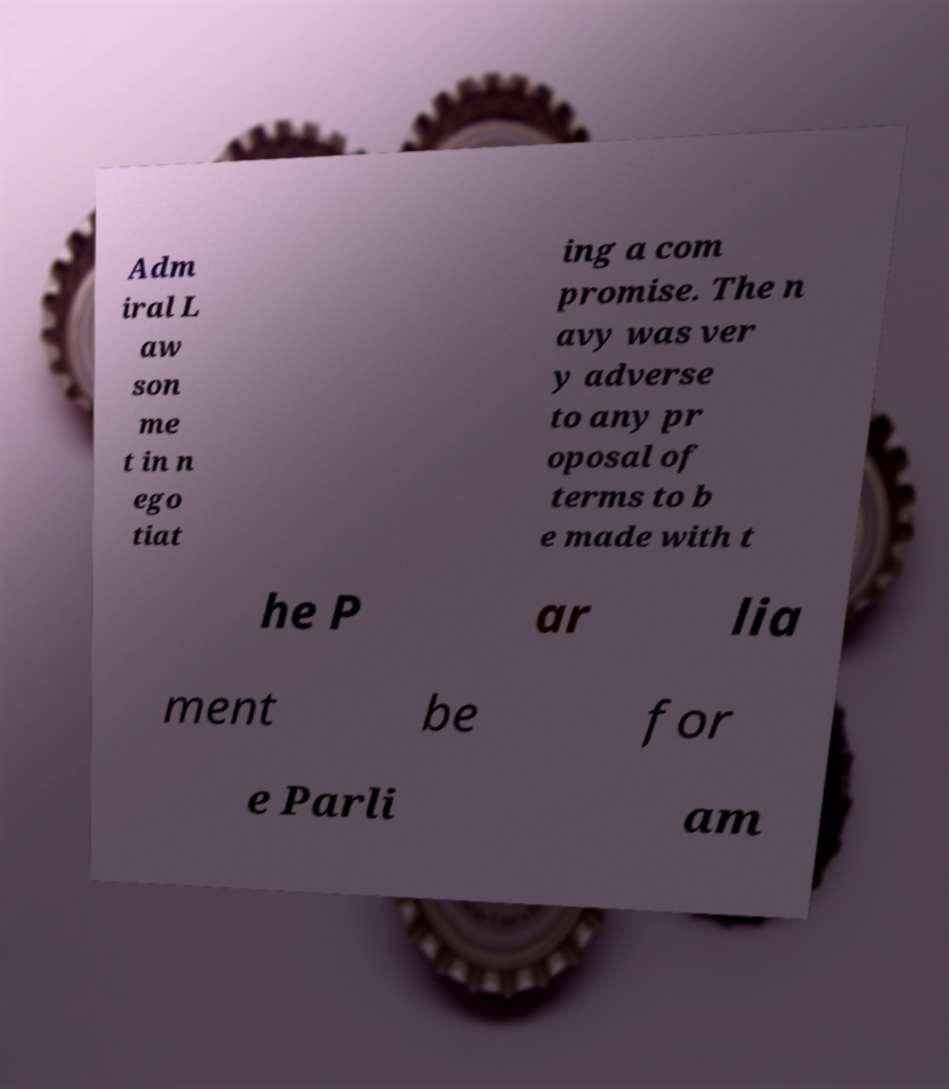Can you accurately transcribe the text from the provided image for me? Adm iral L aw son me t in n ego tiat ing a com promise. The n avy was ver y adverse to any pr oposal of terms to b e made with t he P ar lia ment be for e Parli am 